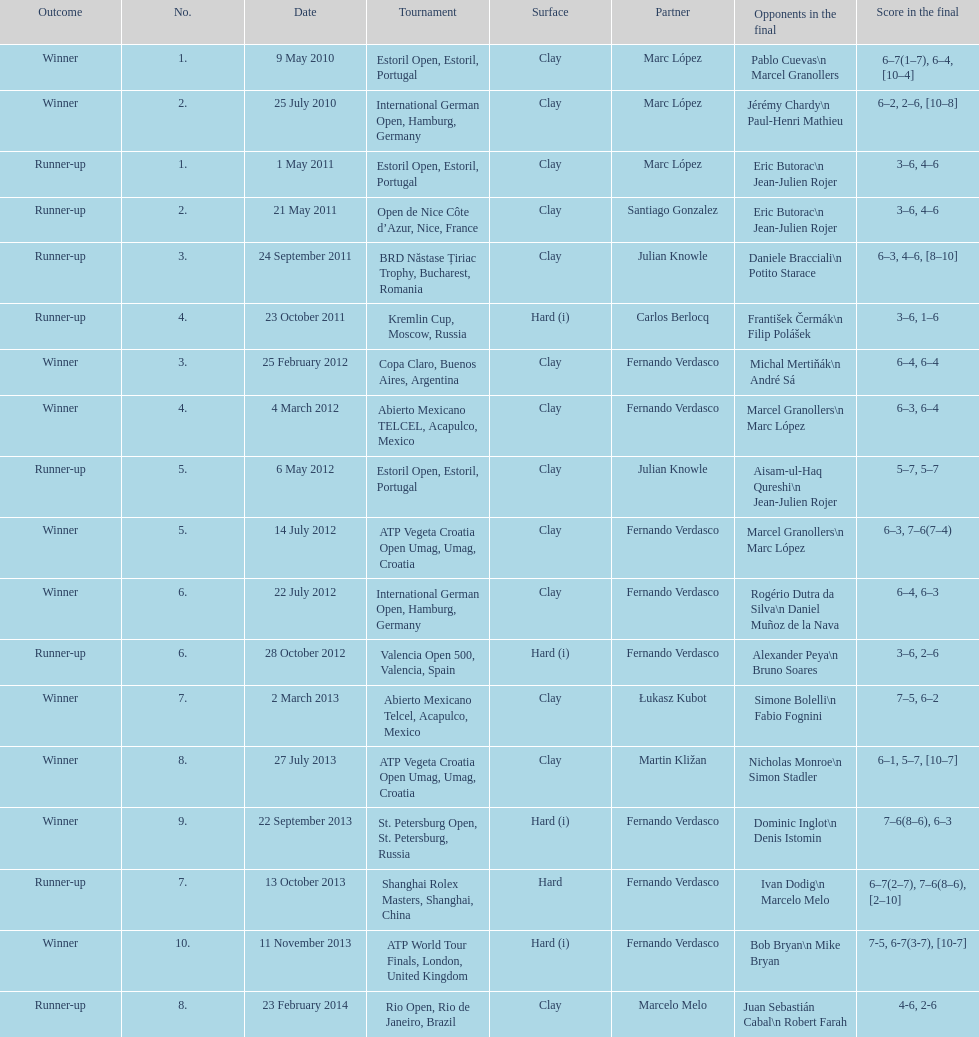Which event holds the biggest number? ATP World Tour Finals. 